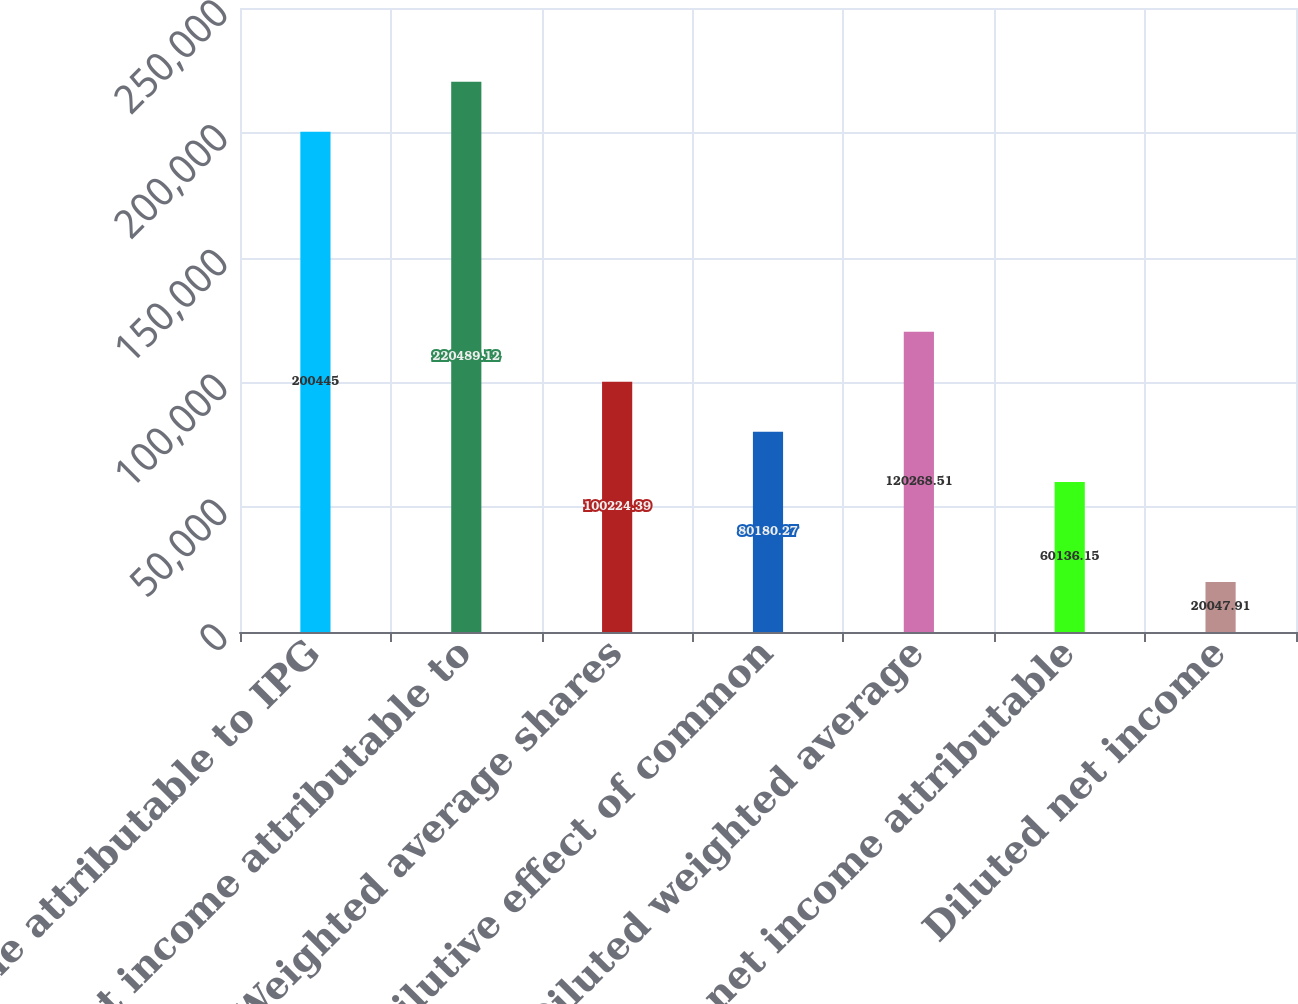Convert chart. <chart><loc_0><loc_0><loc_500><loc_500><bar_chart><fcel>Net income attributable to IPG<fcel>Net income attributable to<fcel>Weighted average shares<fcel>Dilutive effect of common<fcel>Diluted weighted average<fcel>Basic net income attributable<fcel>Diluted net income<nl><fcel>200445<fcel>220489<fcel>100224<fcel>80180.3<fcel>120269<fcel>60136.2<fcel>20047.9<nl></chart> 